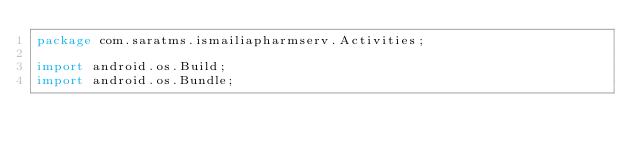<code> <loc_0><loc_0><loc_500><loc_500><_Java_>package com.saratms.ismailiapharmserv.Activities;

import android.os.Build;
import android.os.Bundle;</code> 